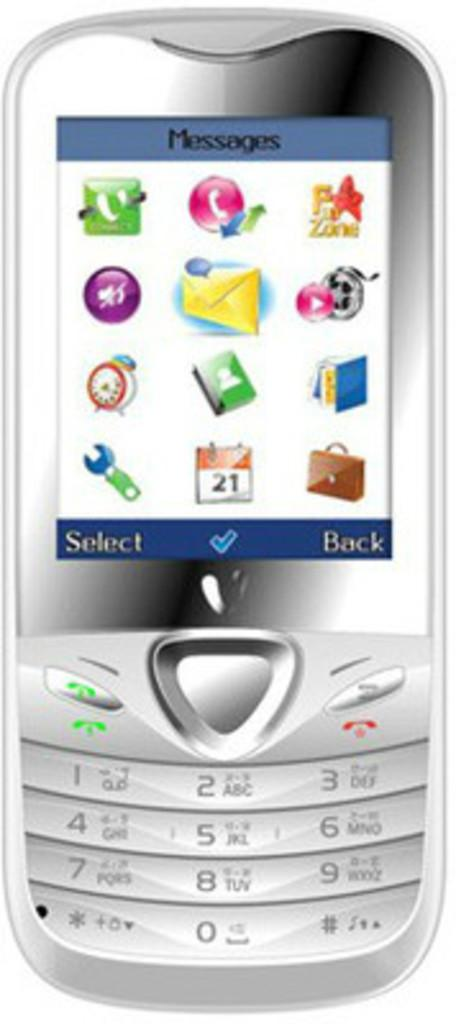<image>
Give a short and clear explanation of the subsequent image. Phone that has icons on it and words select and back at bottom of screen. 